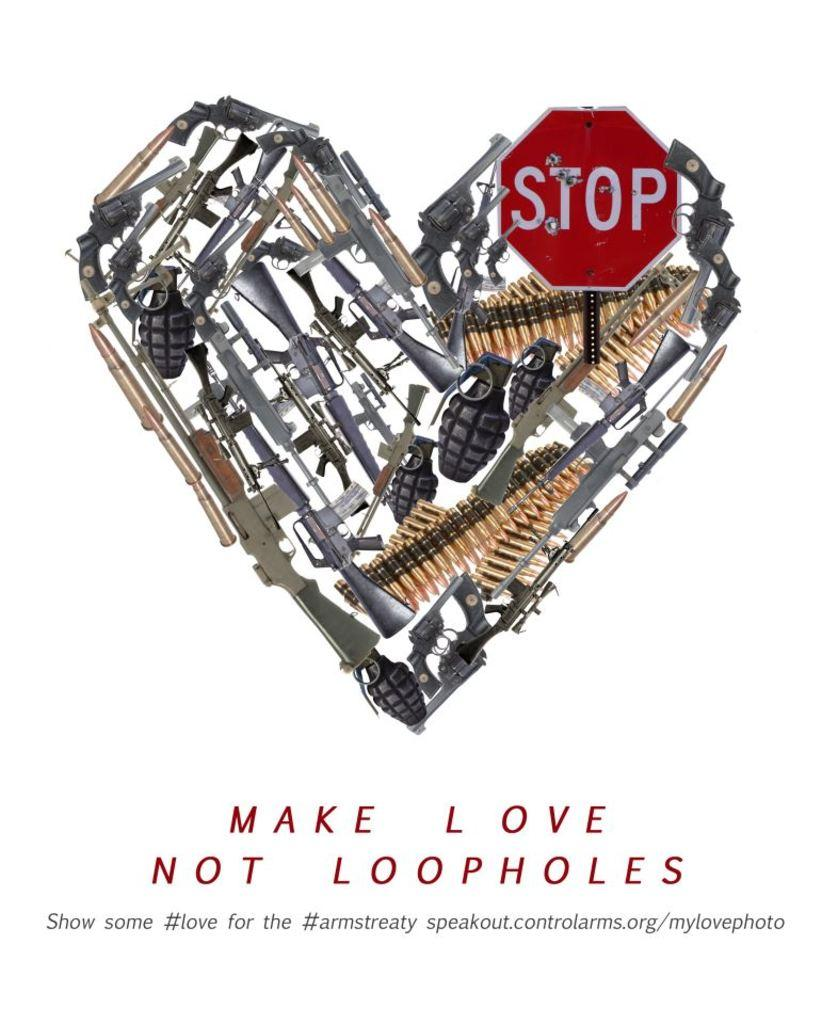<image>
Offer a succinct explanation of the picture presented. A Stop sign and lots of weapons formed in the shape of a heart above Make Love not Loopholes in this #armstreaty ad. 